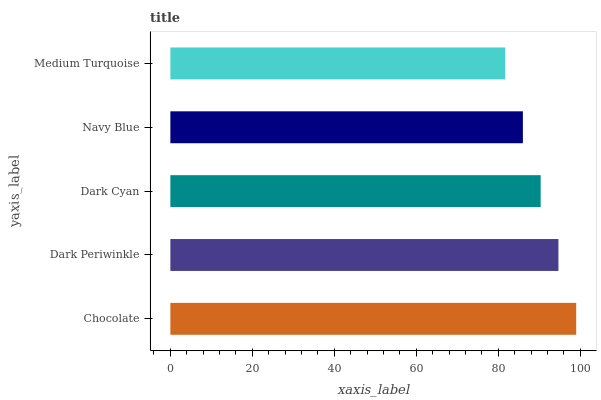Is Medium Turquoise the minimum?
Answer yes or no. Yes. Is Chocolate the maximum?
Answer yes or no. Yes. Is Dark Periwinkle the minimum?
Answer yes or no. No. Is Dark Periwinkle the maximum?
Answer yes or no. No. Is Chocolate greater than Dark Periwinkle?
Answer yes or no. Yes. Is Dark Periwinkle less than Chocolate?
Answer yes or no. Yes. Is Dark Periwinkle greater than Chocolate?
Answer yes or no. No. Is Chocolate less than Dark Periwinkle?
Answer yes or no. No. Is Dark Cyan the high median?
Answer yes or no. Yes. Is Dark Cyan the low median?
Answer yes or no. Yes. Is Dark Periwinkle the high median?
Answer yes or no. No. Is Medium Turquoise the low median?
Answer yes or no. No. 